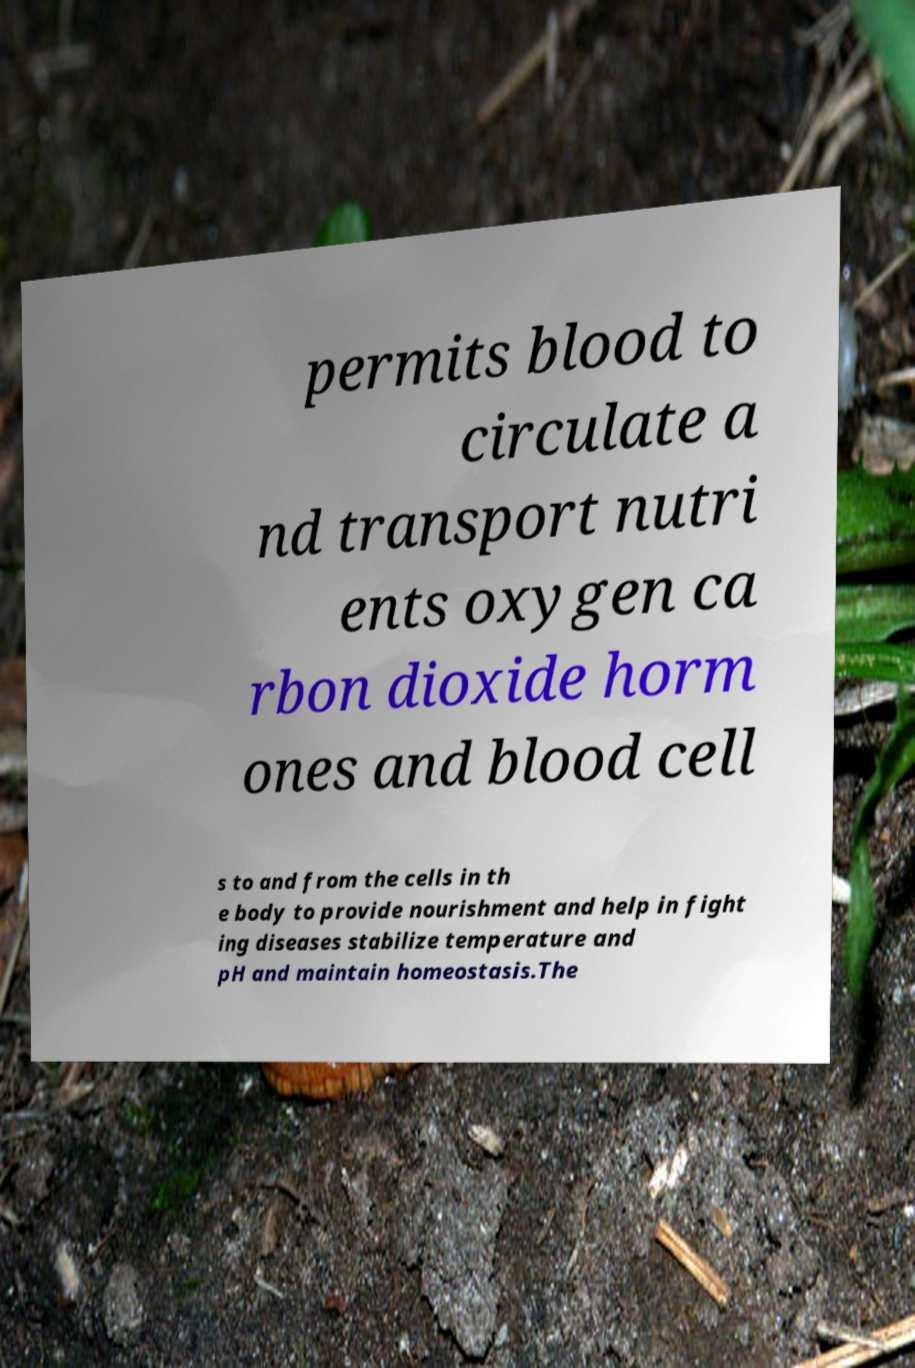Could you assist in decoding the text presented in this image and type it out clearly? permits blood to circulate a nd transport nutri ents oxygen ca rbon dioxide horm ones and blood cell s to and from the cells in th e body to provide nourishment and help in fight ing diseases stabilize temperature and pH and maintain homeostasis.The 